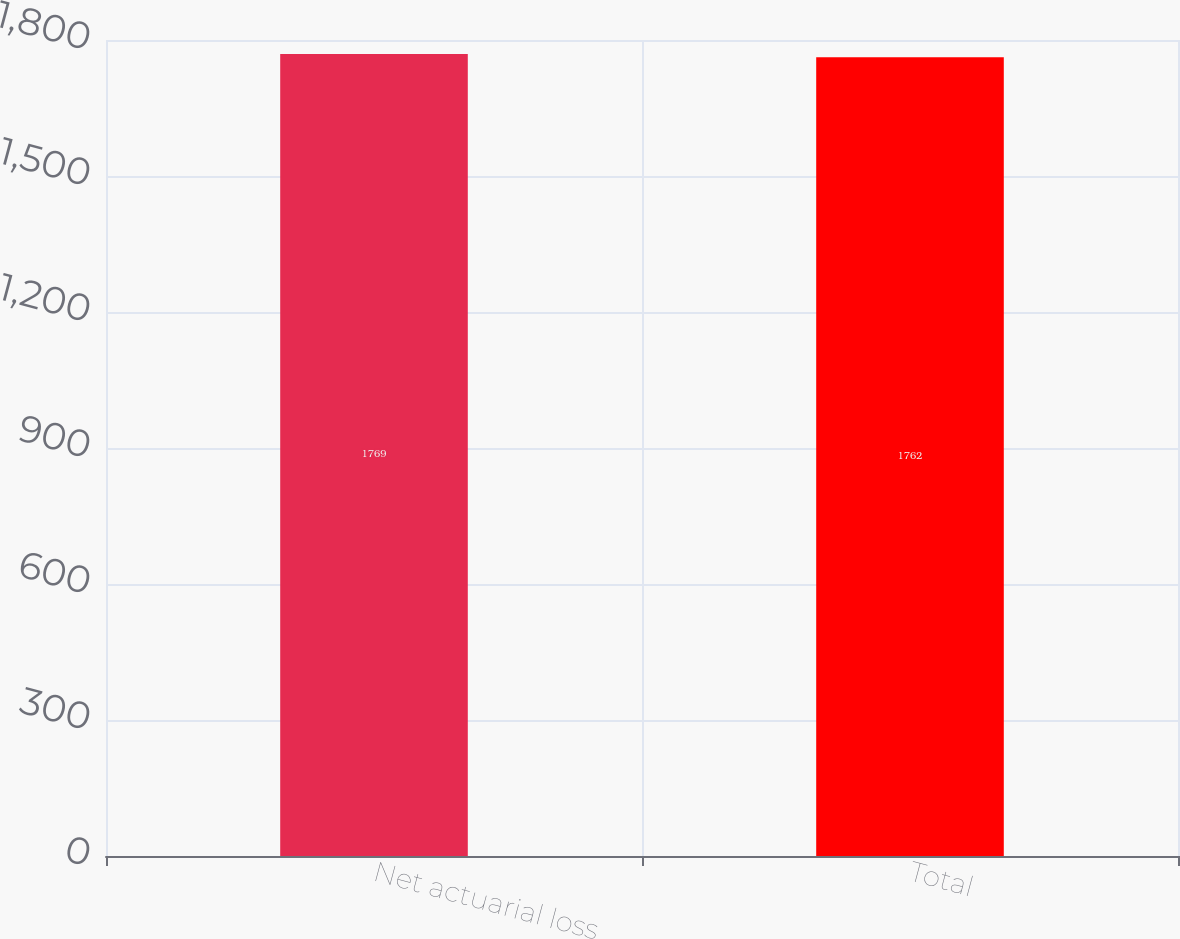<chart> <loc_0><loc_0><loc_500><loc_500><bar_chart><fcel>Net actuarial loss<fcel>Total<nl><fcel>1769<fcel>1762<nl></chart> 